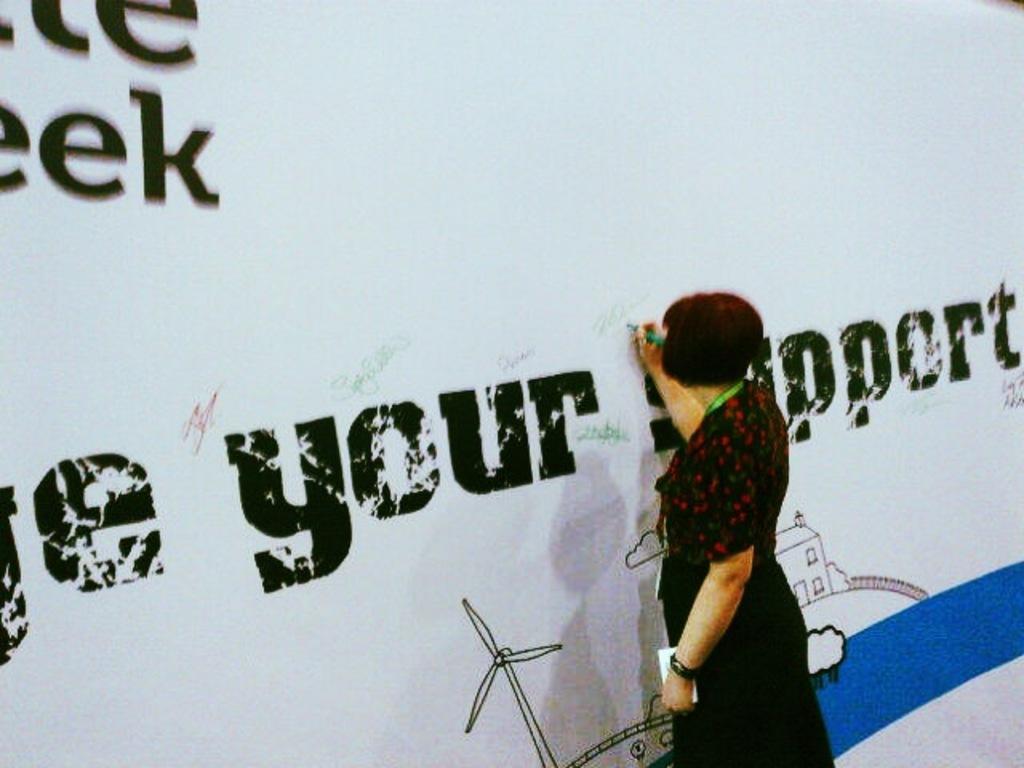Can you describe this image briefly? In this image we can see a woman holding a pen and a paper in her hand is standing. At the top of the image we can see a banner with some text. 